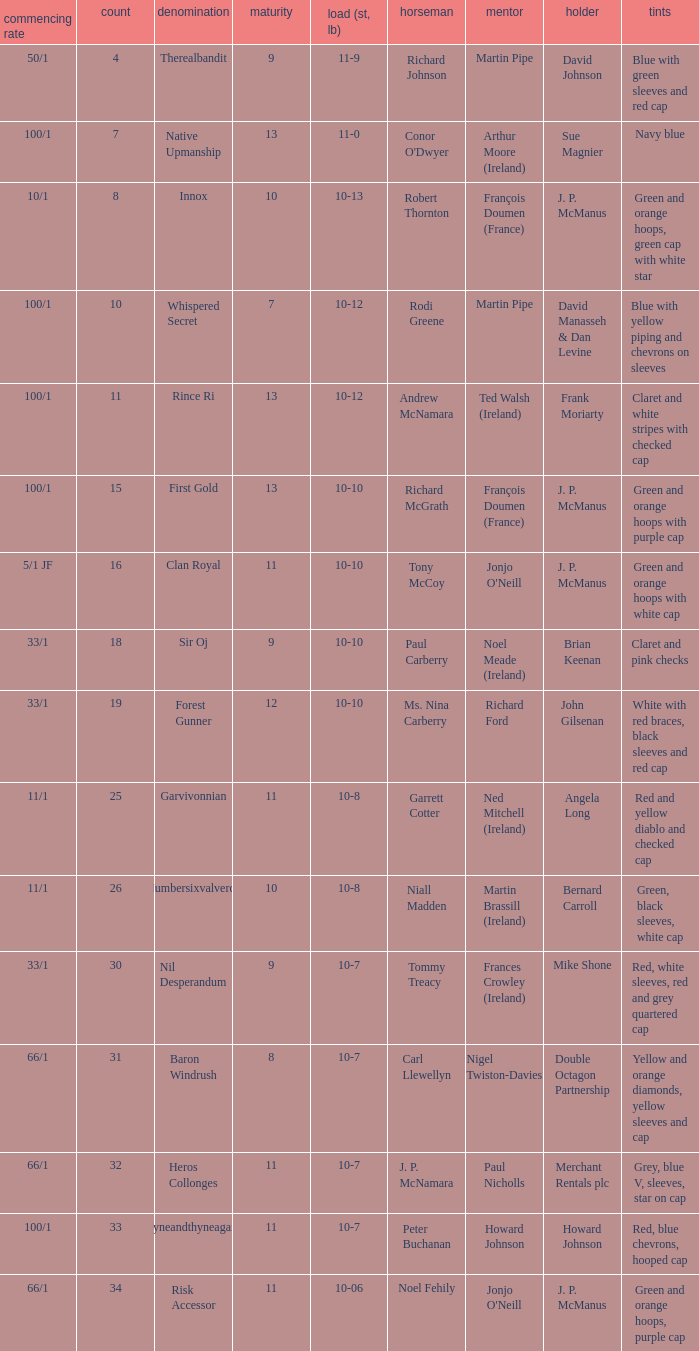What was the name that had a starting price of 11/1 and a jockey named Garrett Cotter? Garvivonnian. 